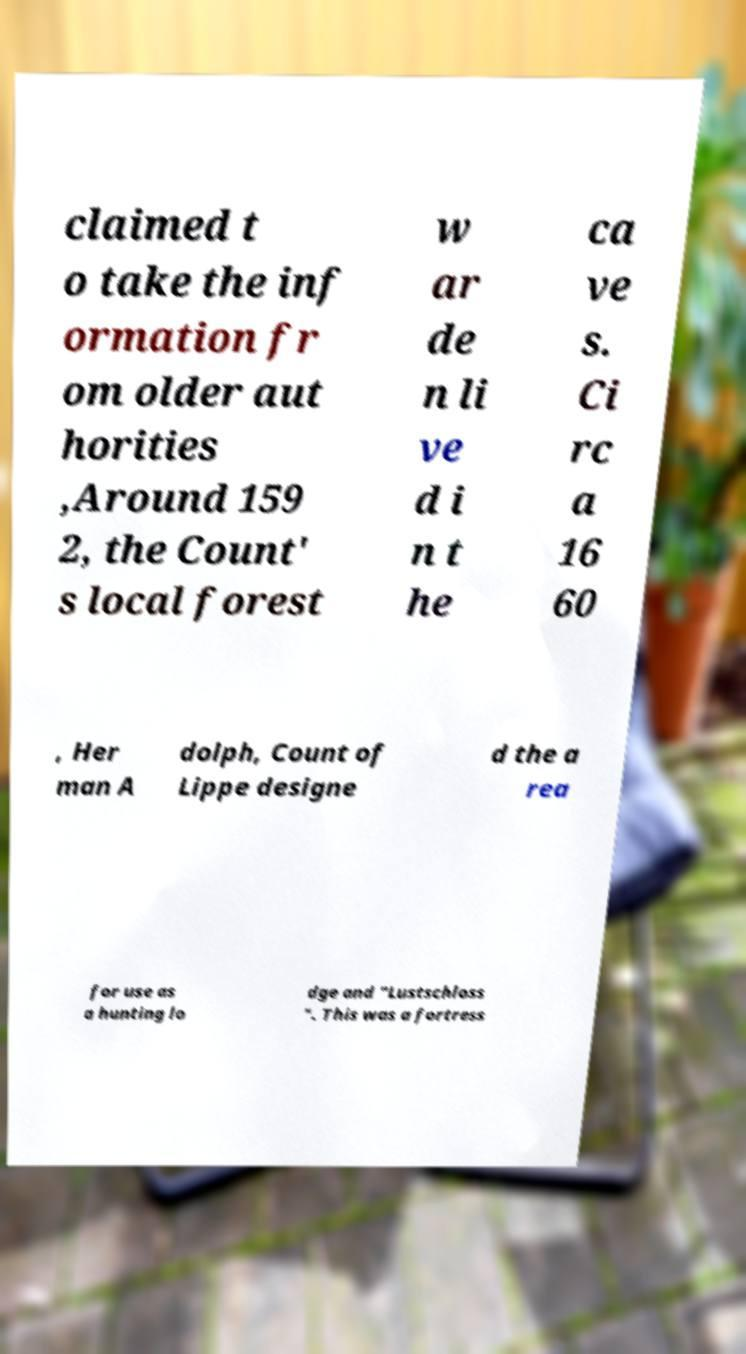Can you read and provide the text displayed in the image?This photo seems to have some interesting text. Can you extract and type it out for me? claimed t o take the inf ormation fr om older aut horities ,Around 159 2, the Count' s local forest w ar de n li ve d i n t he ca ve s. Ci rc a 16 60 , Her man A dolph, Count of Lippe designe d the a rea for use as a hunting lo dge and "Lustschloss ". This was a fortress 